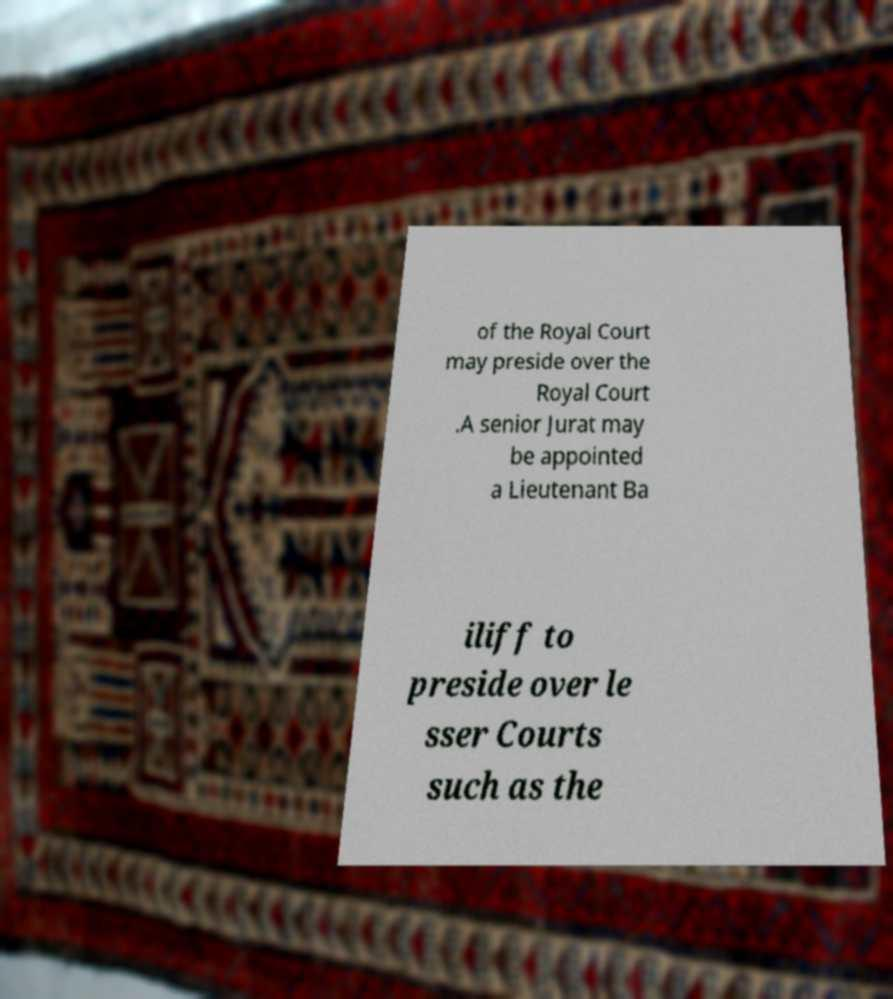Please read and relay the text visible in this image. What does it say? of the Royal Court may preside over the Royal Court .A senior Jurat may be appointed a Lieutenant Ba iliff to preside over le sser Courts such as the 